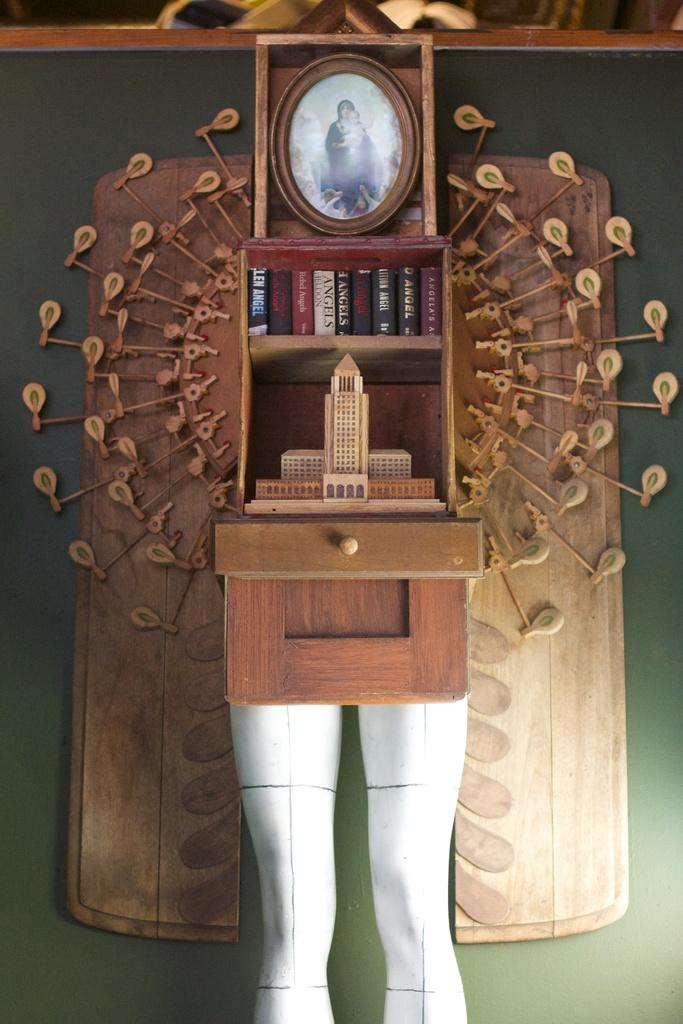What type of items can be found on the shelves in the image? There are books, a frame, and other objects on the shelves. Can you describe the color of one of the objects on the shelves? There is a white color object on the shelves. Are there any decorative elements on the shelves? Yes, there is a decorative object attached to the shelf. What type of board game is being played on the shelves in the image? There is no board game present on the shelves in the image. Is there a box containing a grandfather clock on the shelves? There is no box containing a grandfather clock on the shelves in the image. 